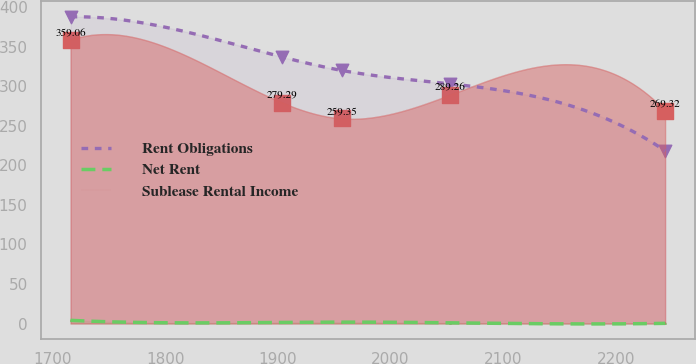Convert chart. <chart><loc_0><loc_0><loc_500><loc_500><line_chart><ecel><fcel>Rent Obligations<fcel>Net Rent<fcel>Sublease Rental Income<nl><fcel>1715.9<fcel>387.94<fcel>3.99<fcel>359.06<nl><fcel>1903.95<fcel>337.05<fcel>1.36<fcel>279.29<nl><fcel>1956.74<fcel>320.11<fcel>1.74<fcel>259.35<nl><fcel>2052.77<fcel>303.17<fcel>0.88<fcel>289.26<nl><fcel>2243.81<fcel>218.53<fcel>0.21<fcel>269.32<nl></chart> 